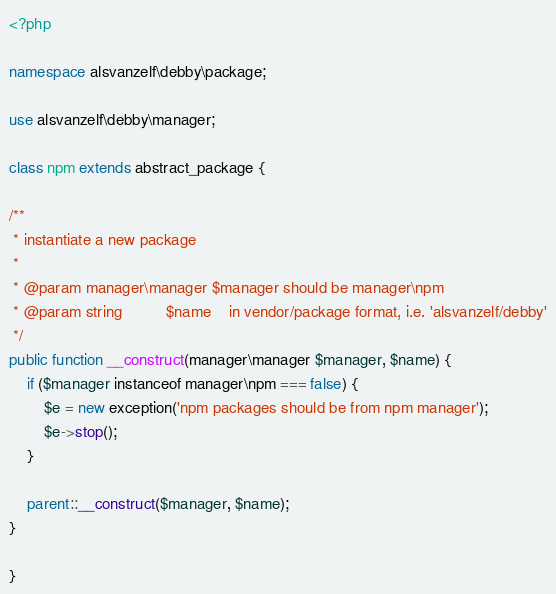Convert code to text. <code><loc_0><loc_0><loc_500><loc_500><_PHP_><?php

namespace alsvanzelf\debby\package;

use alsvanzelf\debby\manager;

class npm extends abstract_package {

/**
 * instantiate a new package
 * 
 * @param manager\manager $manager should be manager\npm
 * @param string          $name    in vendor/package format, i.e. 'alsvanzelf/debby'
 */
public function __construct(manager\manager $manager, $name) {
	if ($manager instanceof manager\npm === false) {
		$e = new exception('npm packages should be from npm manager');
		$e->stop();
	}
	
	parent::__construct($manager, $name);
}

}
</code> 